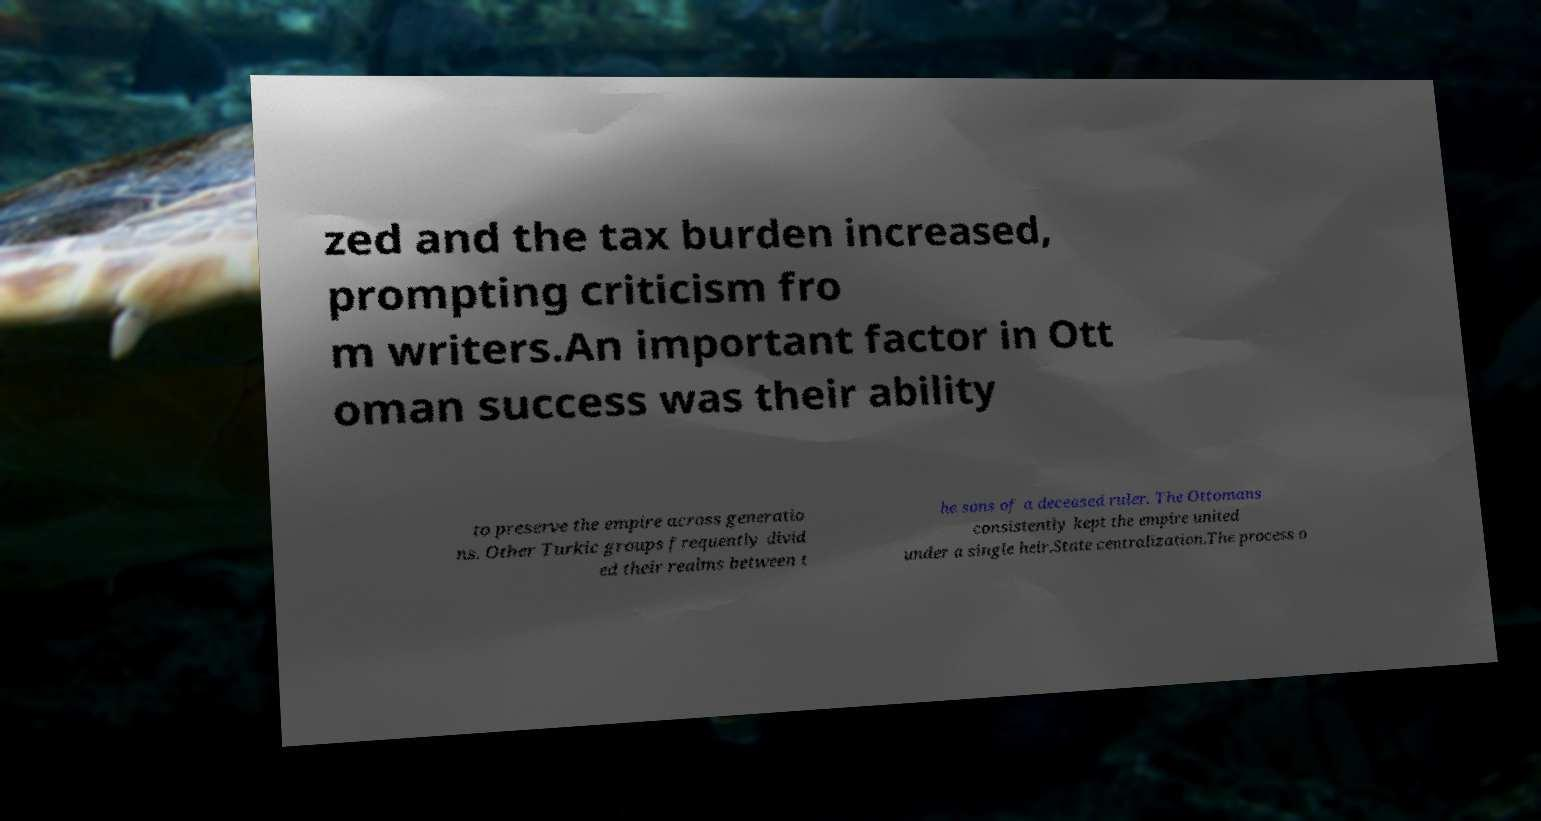Could you extract and type out the text from this image? zed and the tax burden increased, prompting criticism fro m writers.An important factor in Ott oman success was their ability to preserve the empire across generatio ns. Other Turkic groups frequently divid ed their realms between t he sons of a deceased ruler. The Ottomans consistently kept the empire united under a single heir.State centralization.The process o 